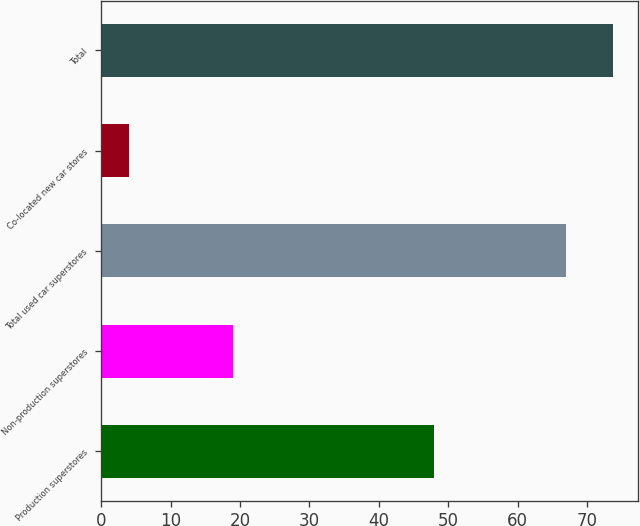<chart> <loc_0><loc_0><loc_500><loc_500><bar_chart><fcel>Production superstores<fcel>Non-production superstores<fcel>Total used car superstores<fcel>Co-located new car stores<fcel>Total<nl><fcel>48<fcel>19<fcel>67<fcel>4<fcel>73.7<nl></chart> 